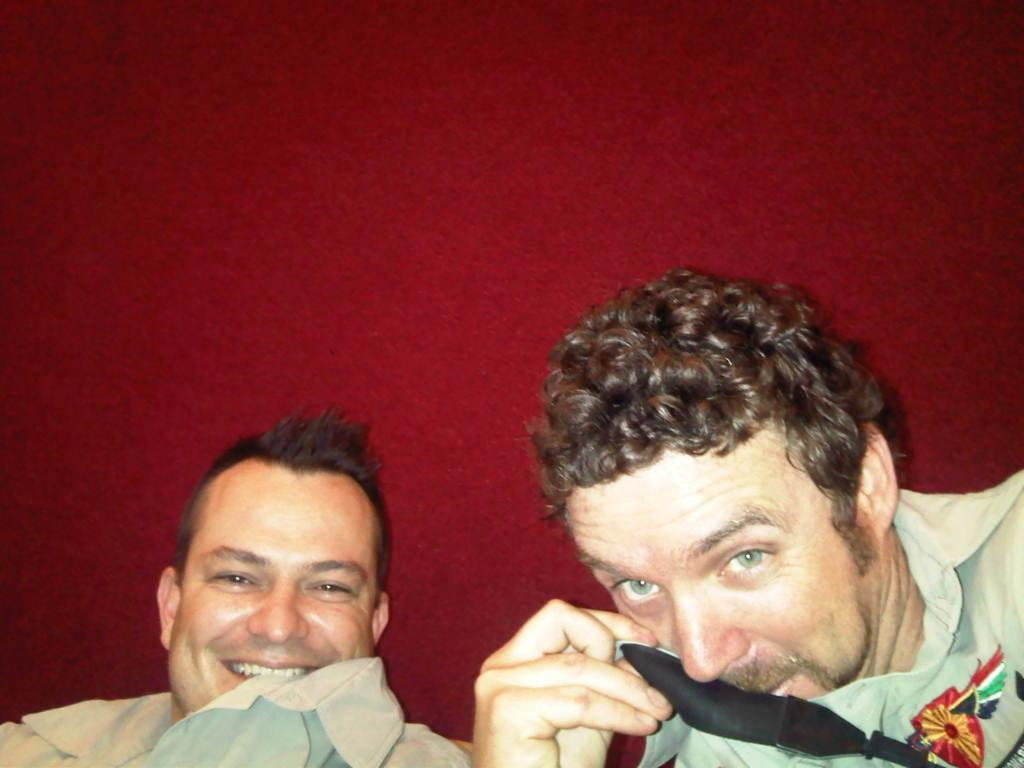How many people are in the image? There are two men in the image. What can be seen in the background of the image? The background of the image is red. What type of card is being used by one of the men in the image? There is no card visible in the image. What is the purpose of the pump in the image? There is no pump present in the image. 